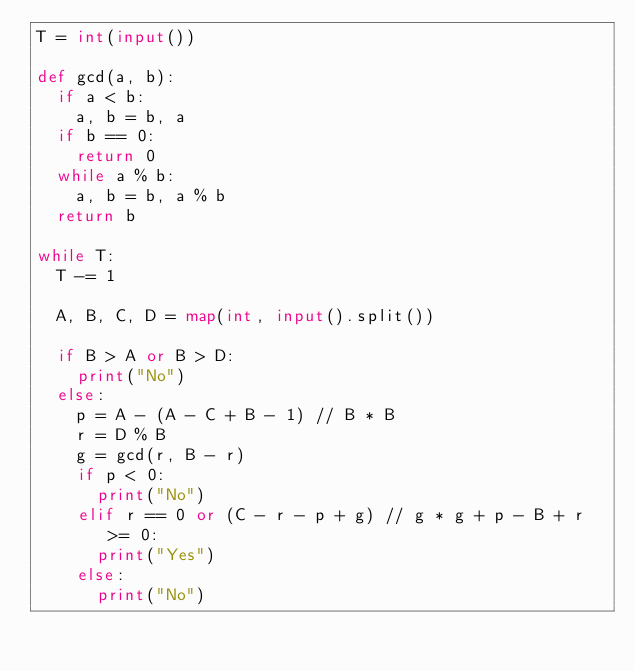<code> <loc_0><loc_0><loc_500><loc_500><_Python_>T = int(input())

def gcd(a, b):
  if a < b:
    a, b = b, a
  if b == 0:
    return 0
  while a % b:
    a, b = b, a % b
  return b

while T:
  T -= 1
  
  A, B, C, D = map(int, input().split())
  
  if B > A or B > D:
    print("No")
  else:
    p = A - (A - C + B - 1) // B * B
    r = D % B
    g = gcd(r, B - r)
    if p < 0:
      print("No")
    elif r == 0 or (C - r - p + g) // g * g + p - B + r >= 0:
      print("Yes")
    else:
      print("No")</code> 